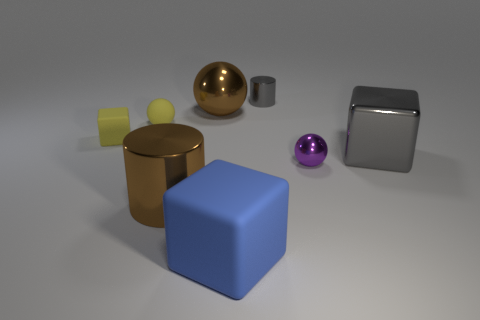Is the tiny matte block the same color as the small rubber ball?
Provide a succinct answer. Yes. Are there an equal number of shiny spheres that are behind the big sphere and large gray metal things that are behind the gray shiny cylinder?
Make the answer very short. Yes. There is a metal ball that is behind the yellow rubber ball in front of the large thing behind the gray cube; what is its color?
Keep it short and to the point. Brown. Is there any other thing that has the same color as the big metallic cylinder?
Your answer should be very brief. Yes. What shape is the metal thing that is the same color as the large metallic cylinder?
Provide a short and direct response. Sphere. There is a rubber block on the left side of the yellow ball; what size is it?
Provide a succinct answer. Small. What is the shape of the gray object that is the same size as the brown metal ball?
Your response must be concise. Cube. Is the gray thing that is behind the small yellow matte block made of the same material as the large block right of the tiny metallic sphere?
Offer a very short reply. Yes. What material is the gray thing behind the big thing that is behind the rubber ball?
Provide a short and direct response. Metal. What size is the metal ball that is to the left of the shiny cylinder that is behind the brown thing that is in front of the big brown sphere?
Make the answer very short. Large. 